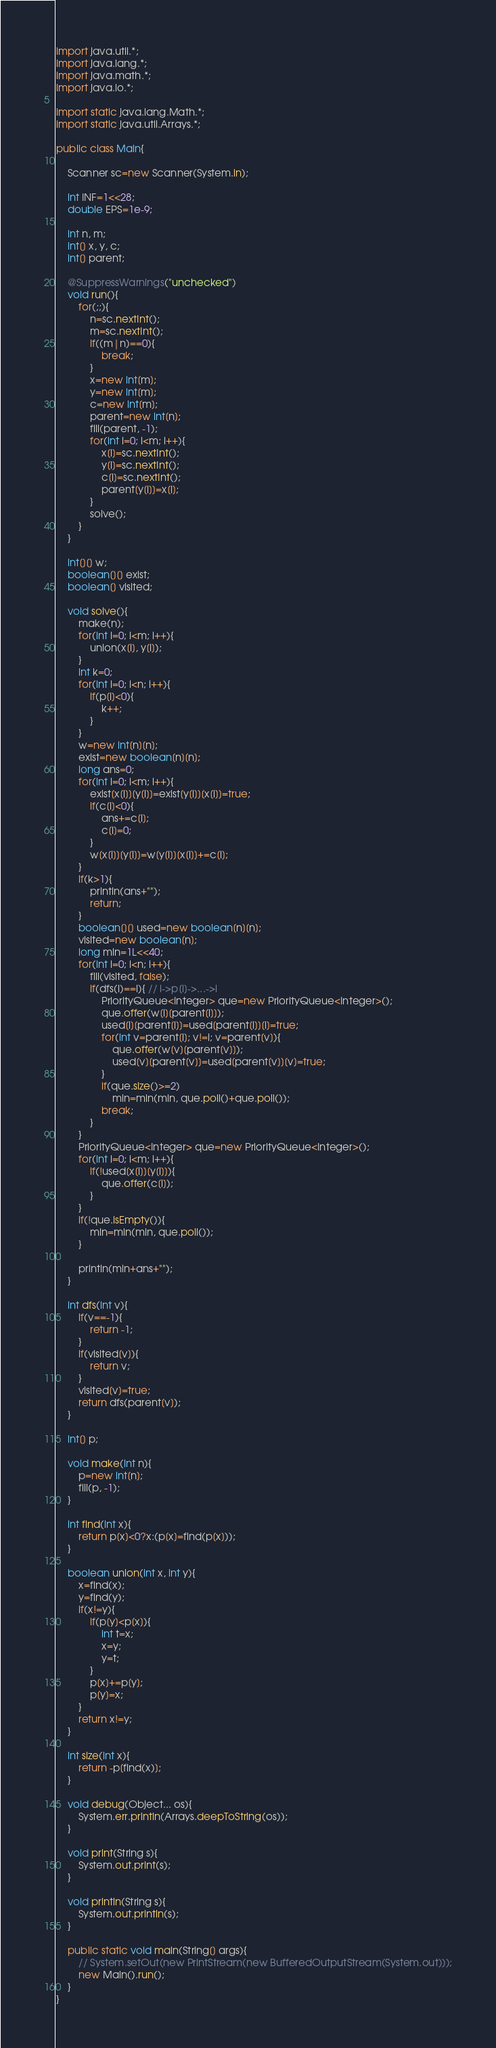Convert code to text. <code><loc_0><loc_0><loc_500><loc_500><_Java_>import java.util.*;
import java.lang.*;
import java.math.*;
import java.io.*;

import static java.lang.Math.*;
import static java.util.Arrays.*;

public class Main{

	Scanner sc=new Scanner(System.in);

	int INF=1<<28;
	double EPS=1e-9;

	int n, m;
	int[] x, y, c;
	int[] parent;

	@SuppressWarnings("unchecked")
	void run(){
		for(;;){
			n=sc.nextInt();
			m=sc.nextInt();
			if((m|n)==0){
				break;
			}
			x=new int[m];
			y=new int[m];
			c=new int[m];
			parent=new int[n];
			fill(parent, -1);
			for(int i=0; i<m; i++){
				x[i]=sc.nextInt();
				y[i]=sc.nextInt();
				c[i]=sc.nextInt();
				parent[y[i]]=x[i];
			}
			solve();
		}
	}

	int[][] w;
	boolean[][] exist;
	boolean[] visited;

	void solve(){
		make(n);
		for(int i=0; i<m; i++){
			union(x[i], y[i]);
		}
		int k=0;
		for(int i=0; i<n; i++){
			if(p[i]<0){
				k++;
			}
		}
		w=new int[n][n];
		exist=new boolean[n][n];
		long ans=0;
		for(int i=0; i<m; i++){
			exist[x[i]][y[i]]=exist[y[i]][x[i]]=true;
			if(c[i]<0){
				ans+=c[i];
				c[i]=0;
			}
			w[x[i]][y[i]]=w[y[i]][x[i]]+=c[i];
		}
		if(k>1){
			println(ans+"");
			return;
		}
		boolean[][] used=new boolean[n][n];
		visited=new boolean[n];
		long min=1L<<40;
		for(int i=0; i<n; i++){
			fill(visited, false);
			if(dfs(i)==i){ // i->p[i]->...->i
				PriorityQueue<Integer> que=new PriorityQueue<Integer>();
				que.offer(w[i][parent[i]]);
				used[i][parent[i]]=used[parent[i]][i]=true;
				for(int v=parent[i]; v!=i; v=parent[v]){
					que.offer(w[v][parent[v]]);
					used[v][parent[v]]=used[parent[v]][v]=true;
				}
				if(que.size()>=2)
					min=min(min, que.poll()+que.poll());
				break;
			}
		}
		PriorityQueue<Integer> que=new PriorityQueue<Integer>();
		for(int i=0; i<m; i++){
			if(!used[x[i]][y[i]]){
				que.offer(c[i]);
			}
		}
		if(!que.isEmpty()){
			min=min(min, que.poll());
		}

		println(min+ans+"");
	}

	int dfs(int v){
		if(v==-1){
			return -1;
		}
		if(visited[v]){
			return v;
		}
		visited[v]=true;
		return dfs(parent[v]);
	}

	int[] p;

	void make(int n){
		p=new int[n];
		fill(p, -1);
	}

	int find(int x){
		return p[x]<0?x:(p[x]=find(p[x]));
	}

	boolean union(int x, int y){
		x=find(x);
		y=find(y);
		if(x!=y){
			if(p[y]<p[x]){
				int t=x;
				x=y;
				y=t;
			}
			p[x]+=p[y];
			p[y]=x;
		}
		return x!=y;
	}

	int size(int x){
		return -p[find(x)];
	}

	void debug(Object... os){
		System.err.println(Arrays.deepToString(os));
	}

	void print(String s){
		System.out.print(s);
	}

	void println(String s){
		System.out.println(s);
	}

	public static void main(String[] args){
		// System.setOut(new PrintStream(new BufferedOutputStream(System.out)));
		new Main().run();
	}
}</code> 